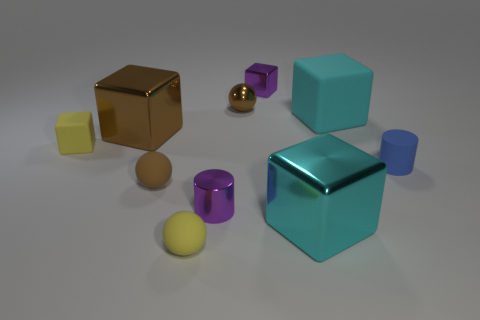Subtract all small yellow rubber blocks. How many blocks are left? 4 Subtract all green cubes. Subtract all cyan cylinders. How many cubes are left? 5 Subtract all spheres. How many objects are left? 7 Subtract 1 brown blocks. How many objects are left? 9 Subtract all tiny yellow matte objects. Subtract all shiny cylinders. How many objects are left? 7 Add 6 tiny rubber things. How many tiny rubber things are left? 10 Add 6 big purple metal balls. How many big purple metal balls exist? 6 